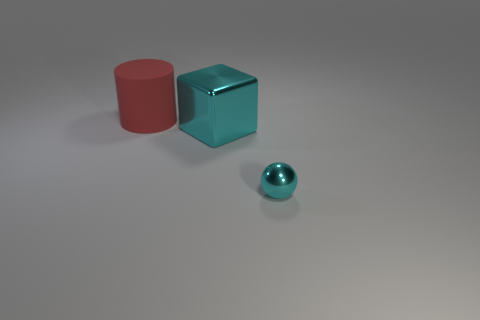Add 2 big metallic objects. How many objects exist? 5 Subtract 1 spheres. How many spheres are left? 0 Subtract all balls. How many objects are left? 2 Add 1 big cyan metal objects. How many big cyan metal objects are left? 2 Add 3 cyan blocks. How many cyan blocks exist? 4 Subtract 0 blue balls. How many objects are left? 3 Subtract all gray blocks. Subtract all cyan things. How many objects are left? 1 